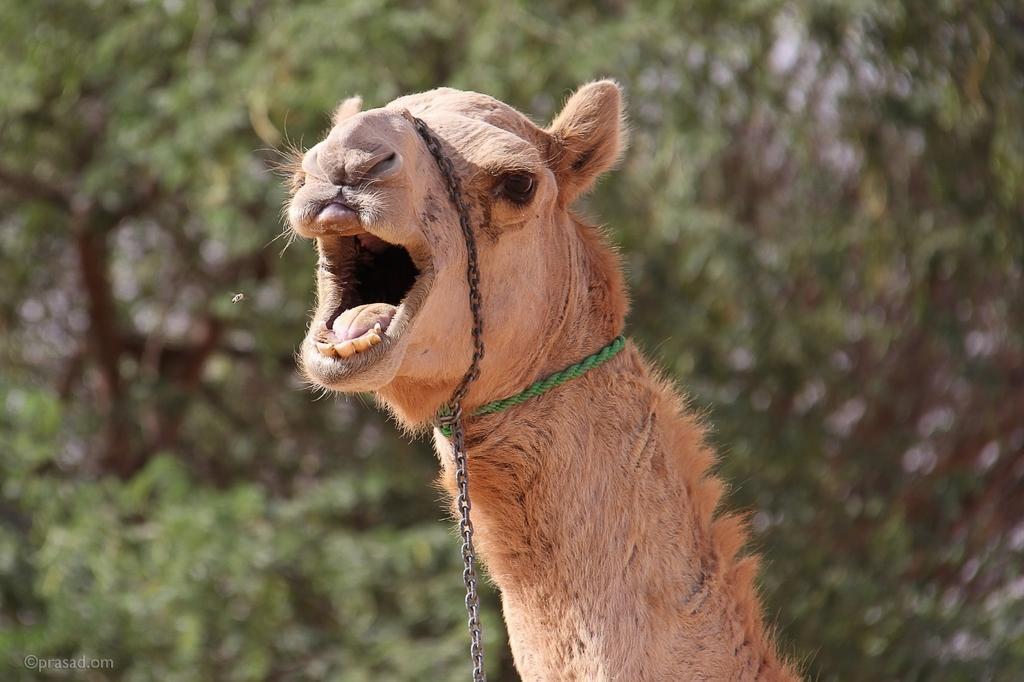In one or two sentences, can you explain what this image depicts? In the middle I can see a camel. In the background I can see trees. This image is taken may be in a zoo. 